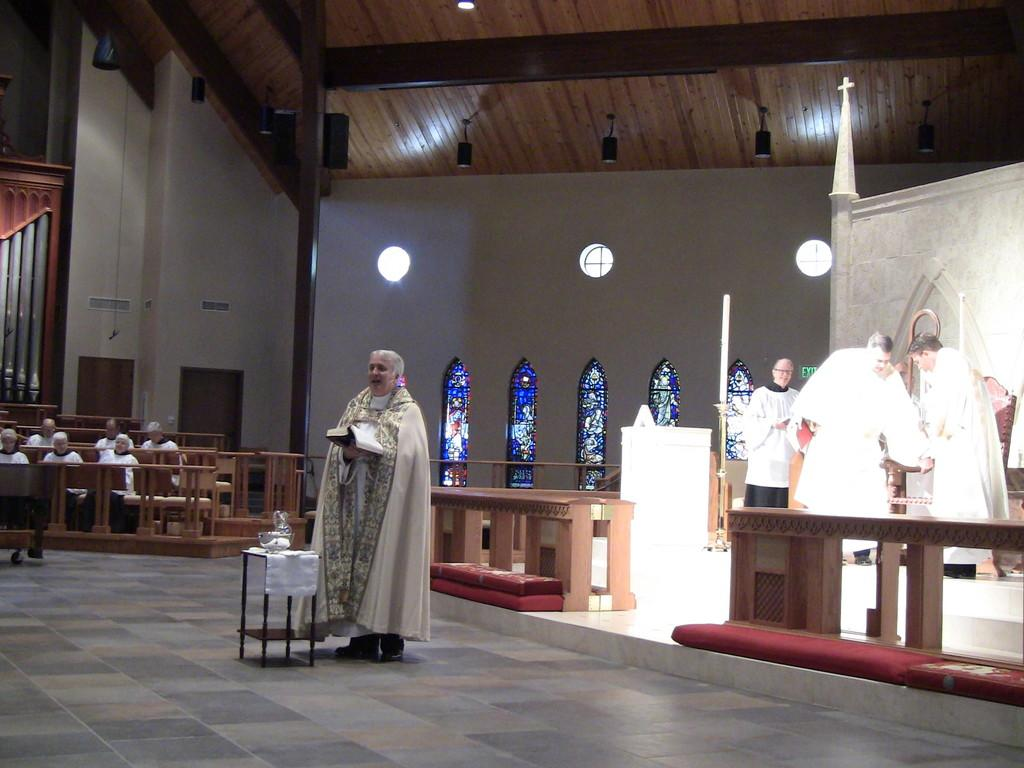What are the people in the image doing? The people in the image are standing and holding a book. Are there any other people in the image? Yes, there are people sitting in the background of the image. What can be seen in the background of the image? A wall is visible in the background of the image. What type of flight is being discussed by the people in the image? There is no mention of a flight or any discussion about it in the image. What color is the skirt worn by the person in the image? There is no person wearing a skirt in the image. 